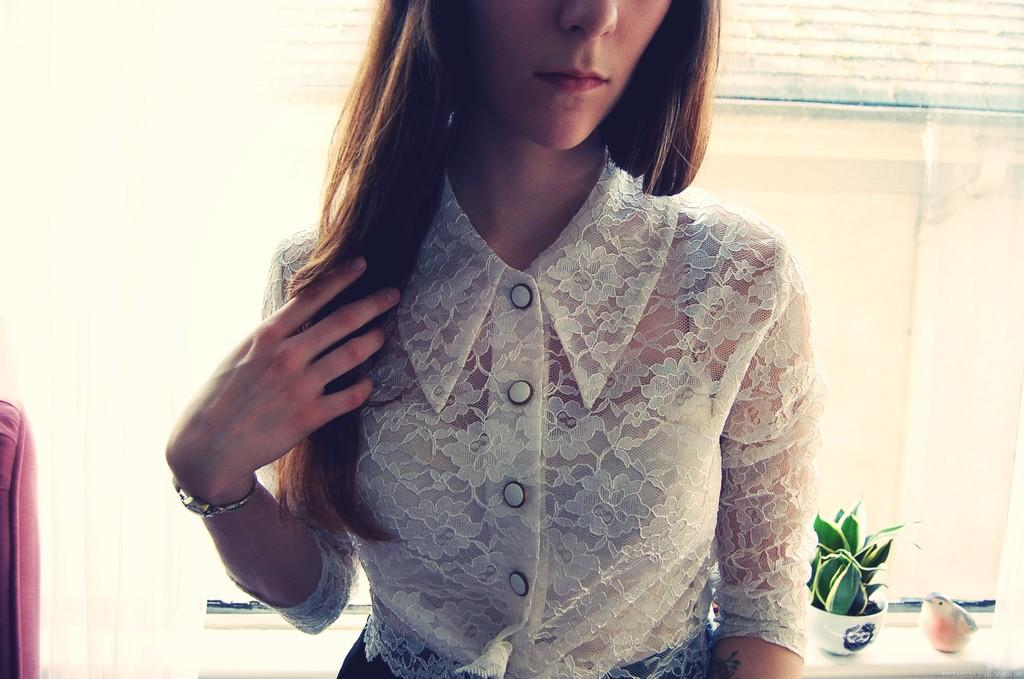Who is present in the image? There is a lady in the image. What is the lady wearing? The lady is wearing a white top. What can be seen in the background of the image? There is a potted plant and a statue in the background of the image. What architectural feature is visible in the image? There is a window in the image. What type of window treatment is present? There are curtains associated with the window. What type of iron is being used by the lady in the image? There is no iron present in the image; the lady is not using any ironing equipment. 